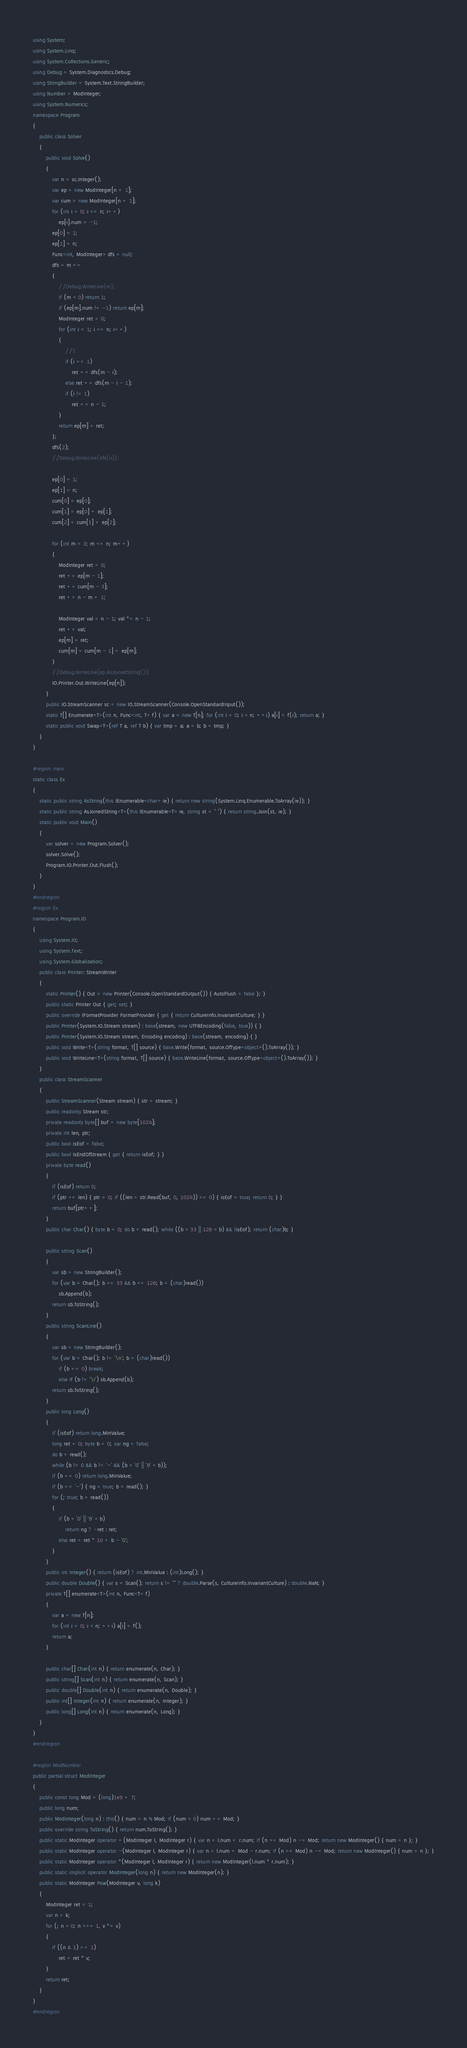Convert code to text. <code><loc_0><loc_0><loc_500><loc_500><_C#_>using System;
using System.Linq;
using System.Collections.Generic;
using Debug = System.Diagnostics.Debug;
using StringBuilder = System.Text.StringBuilder;
using Number = ModInteger;
using System.Numerics;
namespace Program
{
    public class Solver
    {
        public void Solve()
        {
            var n = sc.Integer();
            var ep = new ModInteger[n + 1];
            var cum = new ModInteger[n + 1];
            for (int i = 0; i <= n; i++)
                ep[i].num = -1;
            ep[0] = 1;
            ep[1] = n;
            Func<int, ModInteger> dfs = null;
            dfs = m =>
            {
                //Debug.WriteLine(m);
                if (m < 0) return 1;
                if (ep[m].num != -1) return ep[m];
                ModInteger ret = 0;
                for (int i = 1; i <= n; i++)
                {
                    //1
                    if (i == 1)
                        ret += dfs(m - i);
                    else ret += dfs(m - i - 1);
                    if (i != 1)
                        ret += n - 1;
                }
                return ep[m] = ret;
            };
            dfs(2);
            //Debug.WriteLine(dfs(n));

            ep[0] = 1;
            ep[1] = n;
            cum[0] = ep[0];
            cum[1] = ep[0] + ep[1];
            cum[2] = cum[1] + ep[2];

            for (int m = 3; m <= n; m++)
            {
                ModInteger ret = 0;
                ret += ep[m - 1];
                ret += cum[m - 3];
                ret += n - m + 1;

                ModInteger val = n - 1; val *= n - 1;
                ret += val;
                ep[m] = ret;
                cum[m] = cum[m - 1] + ep[m];
            }
            //Debug.WriteLine(ep.AsJoinedString());
            IO.Printer.Out.WriteLine(ep[n]);
        }
        public IO.StreamScanner sc = new IO.StreamScanner(Console.OpenStandardInput());
        static T[] Enumerate<T>(int n, Func<int, T> f) { var a = new T[n]; for (int i = 0; i < n; ++i) a[i] = f(i); return a; }
        static public void Swap<T>(ref T a, ref T b) { var tmp = a; a = b; b = tmp; }
    }
}

#region main
static class Ex
{
    static public string AsString(this IEnumerable<char> ie) { return new string(System.Linq.Enumerable.ToArray(ie)); }
    static public string AsJoinedString<T>(this IEnumerable<T> ie, string st = " ") { return string.Join(st, ie); }
    static public void Main()
    {
        var solver = new Program.Solver();
        solver.Solve();
        Program.IO.Printer.Out.Flush();
    }
}
#endregion
#region Ex
namespace Program.IO
{
    using System.IO;
    using System.Text;
    using System.Globalization;
    public class Printer: StreamWriter
    {
        static Printer() { Out = new Printer(Console.OpenStandardOutput()) { AutoFlush = false }; }
        public static Printer Out { get; set; }
        public override IFormatProvider FormatProvider { get { return CultureInfo.InvariantCulture; } }
        public Printer(System.IO.Stream stream) : base(stream, new UTF8Encoding(false, true)) { }
        public Printer(System.IO.Stream stream, Encoding encoding) : base(stream, encoding) { }
        public void Write<T>(string format, T[] source) { base.Write(format, source.OfType<object>().ToArray()); }
        public void WriteLine<T>(string format, T[] source) { base.WriteLine(format, source.OfType<object>().ToArray()); }
    }
    public class StreamScanner
    {
        public StreamScanner(Stream stream) { str = stream; }
        public readonly Stream str;
        private readonly byte[] buf = new byte[1024];
        private int len, ptr;
        public bool isEof = false;
        public bool IsEndOfStream { get { return isEof; } }
        private byte read()
        {
            if (isEof) return 0;
            if (ptr >= len) { ptr = 0; if ((len = str.Read(buf, 0, 1024)) <= 0) { isEof = true; return 0; } }
            return buf[ptr++];
        }
        public char Char() { byte b = 0; do b = read(); while ((b < 33 || 126 < b) && !isEof); return (char)b; }

        public string Scan()
        {
            var sb = new StringBuilder();
            for (var b = Char(); b >= 33 && b <= 126; b = (char)read())
                sb.Append(b);
            return sb.ToString();
        }
        public string ScanLine()
        {
            var sb = new StringBuilder();
            for (var b = Char(); b != '\n'; b = (char)read())
                if (b == 0) break;
                else if (b != '\r') sb.Append(b);
            return sb.ToString();
        }
        public long Long()
        {
            if (isEof) return long.MinValue;
            long ret = 0; byte b = 0; var ng = false;
            do b = read();
            while (b != 0 && b != '-' && (b < '0' || '9' < b));
            if (b == 0) return long.MinValue;
            if (b == '-') { ng = true; b = read(); }
            for (; true; b = read())
            {
                if (b < '0' || '9' < b)
                    return ng ? -ret : ret;
                else ret = ret * 10 + b - '0';
            }
        }
        public int Integer() { return (isEof) ? int.MinValue : (int)Long(); }
        public double Double() { var s = Scan(); return s != "" ? double.Parse(s, CultureInfo.InvariantCulture) : double.NaN; }
        private T[] enumerate<T>(int n, Func<T> f)
        {
            var a = new T[n];
            for (int i = 0; i < n; ++i) a[i] = f();
            return a;
        }

        public char[] Char(int n) { return enumerate(n, Char); }
        public string[] Scan(int n) { return enumerate(n, Scan); }
        public double[] Double(int n) { return enumerate(n, Double); }
        public int[] Integer(int n) { return enumerate(n, Integer); }
        public long[] Long(int n) { return enumerate(n, Long); }
    }
}
#endregion

#region ModNumber
public partial struct ModInteger
{
    public const long Mod = (long)1e9 + 7;
    public long num;
    public ModInteger(long n) : this() { num = n % Mod; if (num < 0) num += Mod; }
    public override string ToString() { return num.ToString(); }
    public static ModInteger operator +(ModInteger l, ModInteger r) { var n = l.num + r.num; if (n >= Mod) n -= Mod; return new ModInteger() { num = n }; }
    public static ModInteger operator -(ModInteger l, ModInteger r) { var n = l.num + Mod - r.num; if (n >= Mod) n -= Mod; return new ModInteger() { num = n }; }
    public static ModInteger operator *(ModInteger l, ModInteger r) { return new ModInteger(l.num * r.num); }
    public static implicit operator ModInteger(long n) { return new ModInteger(n); }
    public static ModInteger Pow(ModInteger v, long k)
    {
        ModInteger ret = 1;
        var n = k;
        for (; n > 0; n >>= 1, v *= v)
        {
            if ((n & 1) == 1)
                ret = ret * v;
        }
        return ret;
    }
}
#endregion
</code> 